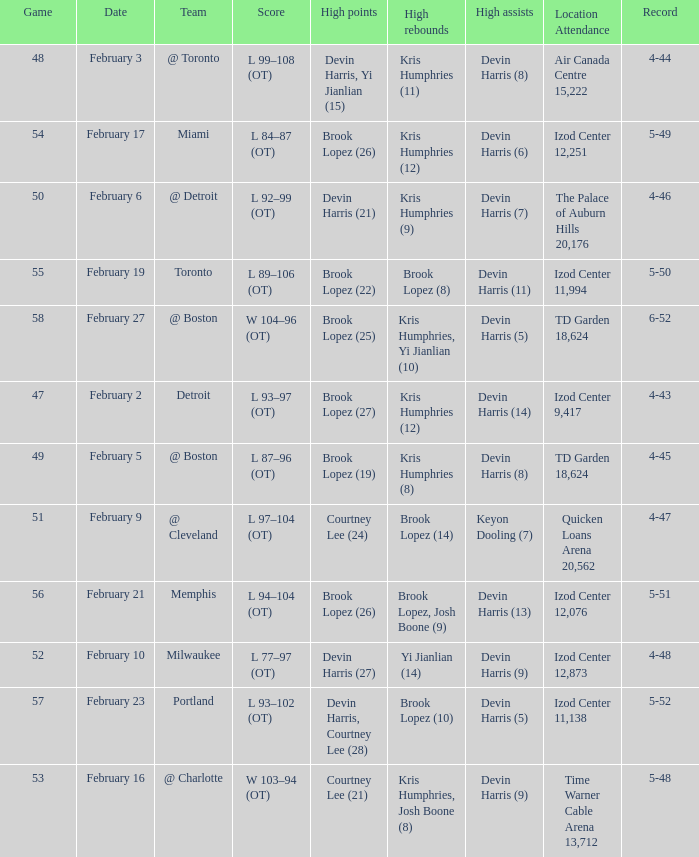Would you mind parsing the complete table? {'header': ['Game', 'Date', 'Team', 'Score', 'High points', 'High rebounds', 'High assists', 'Location Attendance', 'Record'], 'rows': [['48', 'February 3', '@ Toronto', 'L 99–108 (OT)', 'Devin Harris, Yi Jianlian (15)', 'Kris Humphries (11)', 'Devin Harris (8)', 'Air Canada Centre 15,222', '4-44'], ['54', 'February 17', 'Miami', 'L 84–87 (OT)', 'Brook Lopez (26)', 'Kris Humphries (12)', 'Devin Harris (6)', 'Izod Center 12,251', '5-49'], ['50', 'February 6', '@ Detroit', 'L 92–99 (OT)', 'Devin Harris (21)', 'Kris Humphries (9)', 'Devin Harris (7)', 'The Palace of Auburn Hills 20,176', '4-46'], ['55', 'February 19', 'Toronto', 'L 89–106 (OT)', 'Brook Lopez (22)', 'Brook Lopez (8)', 'Devin Harris (11)', 'Izod Center 11,994', '5-50'], ['58', 'February 27', '@ Boston', 'W 104–96 (OT)', 'Brook Lopez (25)', 'Kris Humphries, Yi Jianlian (10)', 'Devin Harris (5)', 'TD Garden 18,624', '6-52'], ['47', 'February 2', 'Detroit', 'L 93–97 (OT)', 'Brook Lopez (27)', 'Kris Humphries (12)', 'Devin Harris (14)', 'Izod Center 9,417', '4-43'], ['49', 'February 5', '@ Boston', 'L 87–96 (OT)', 'Brook Lopez (19)', 'Kris Humphries (8)', 'Devin Harris (8)', 'TD Garden 18,624', '4-45'], ['51', 'February 9', '@ Cleveland', 'L 97–104 (OT)', 'Courtney Lee (24)', 'Brook Lopez (14)', 'Keyon Dooling (7)', 'Quicken Loans Arena 20,562', '4-47'], ['56', 'February 21', 'Memphis', 'L 94–104 (OT)', 'Brook Lopez (26)', 'Brook Lopez, Josh Boone (9)', 'Devin Harris (13)', 'Izod Center 12,076', '5-51'], ['52', 'February 10', 'Milwaukee', 'L 77–97 (OT)', 'Devin Harris (27)', 'Yi Jianlian (14)', 'Devin Harris (9)', 'Izod Center 12,873', '4-48'], ['57', 'February 23', 'Portland', 'L 93–102 (OT)', 'Devin Harris, Courtney Lee (28)', 'Brook Lopez (10)', 'Devin Harris (5)', 'Izod Center 11,138', '5-52'], ['53', 'February 16', '@ Charlotte', 'W 103–94 (OT)', 'Courtney Lee (21)', 'Kris Humphries, Josh Boone (8)', 'Devin Harris (9)', 'Time Warner Cable Arena 13,712', '5-48']]} What was the record in the game against Memphis? 5-51. 